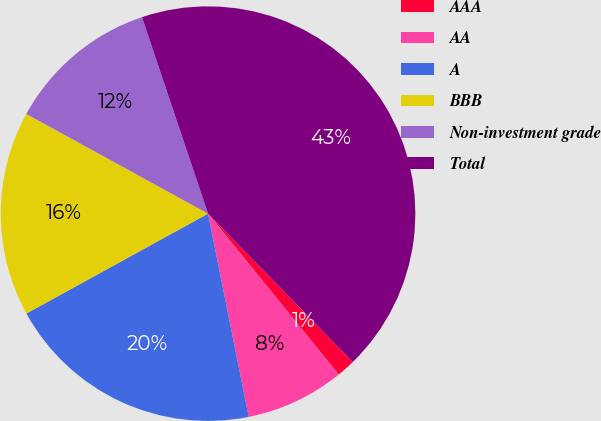Convert chart to OTSL. <chart><loc_0><loc_0><loc_500><loc_500><pie_chart><fcel>AAA<fcel>AA<fcel>A<fcel>BBB<fcel>Non-investment grade<fcel>Total<nl><fcel>1.45%<fcel>7.71%<fcel>20.14%<fcel>15.99%<fcel>11.85%<fcel>42.86%<nl></chart> 